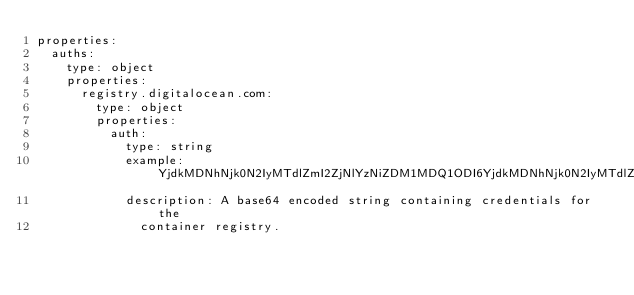Convert code to text. <code><loc_0><loc_0><loc_500><loc_500><_YAML_>properties:
  auths:
    type: object
    properties:
      registry.digitalocean.com:
        type: object
        properties:
          auth:
            type: string
            example: YjdkMDNhNjk0N2IyMTdlZmI2ZjNlYzNiZDM1MDQ1ODI6YjdkMDNhNjk0N2IyMTdlZmI2ZjNlYzNiZDM1MDQ1ODIK
            description: A base64 encoded string containing credentials for the
              container registry.</code> 